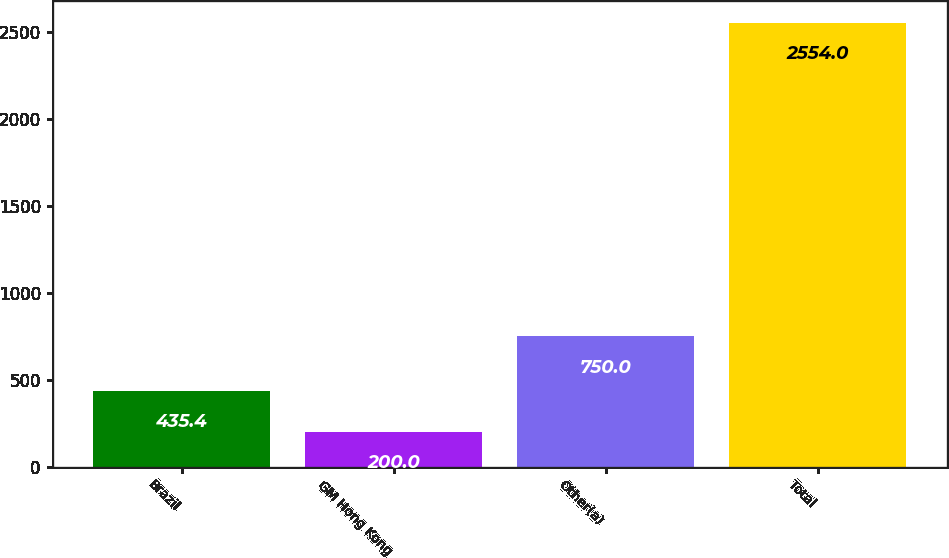Convert chart. <chart><loc_0><loc_0><loc_500><loc_500><bar_chart><fcel>Brazil<fcel>GM Hong Kong<fcel>Other(a)<fcel>Total<nl><fcel>435.4<fcel>200<fcel>750<fcel>2554<nl></chart> 